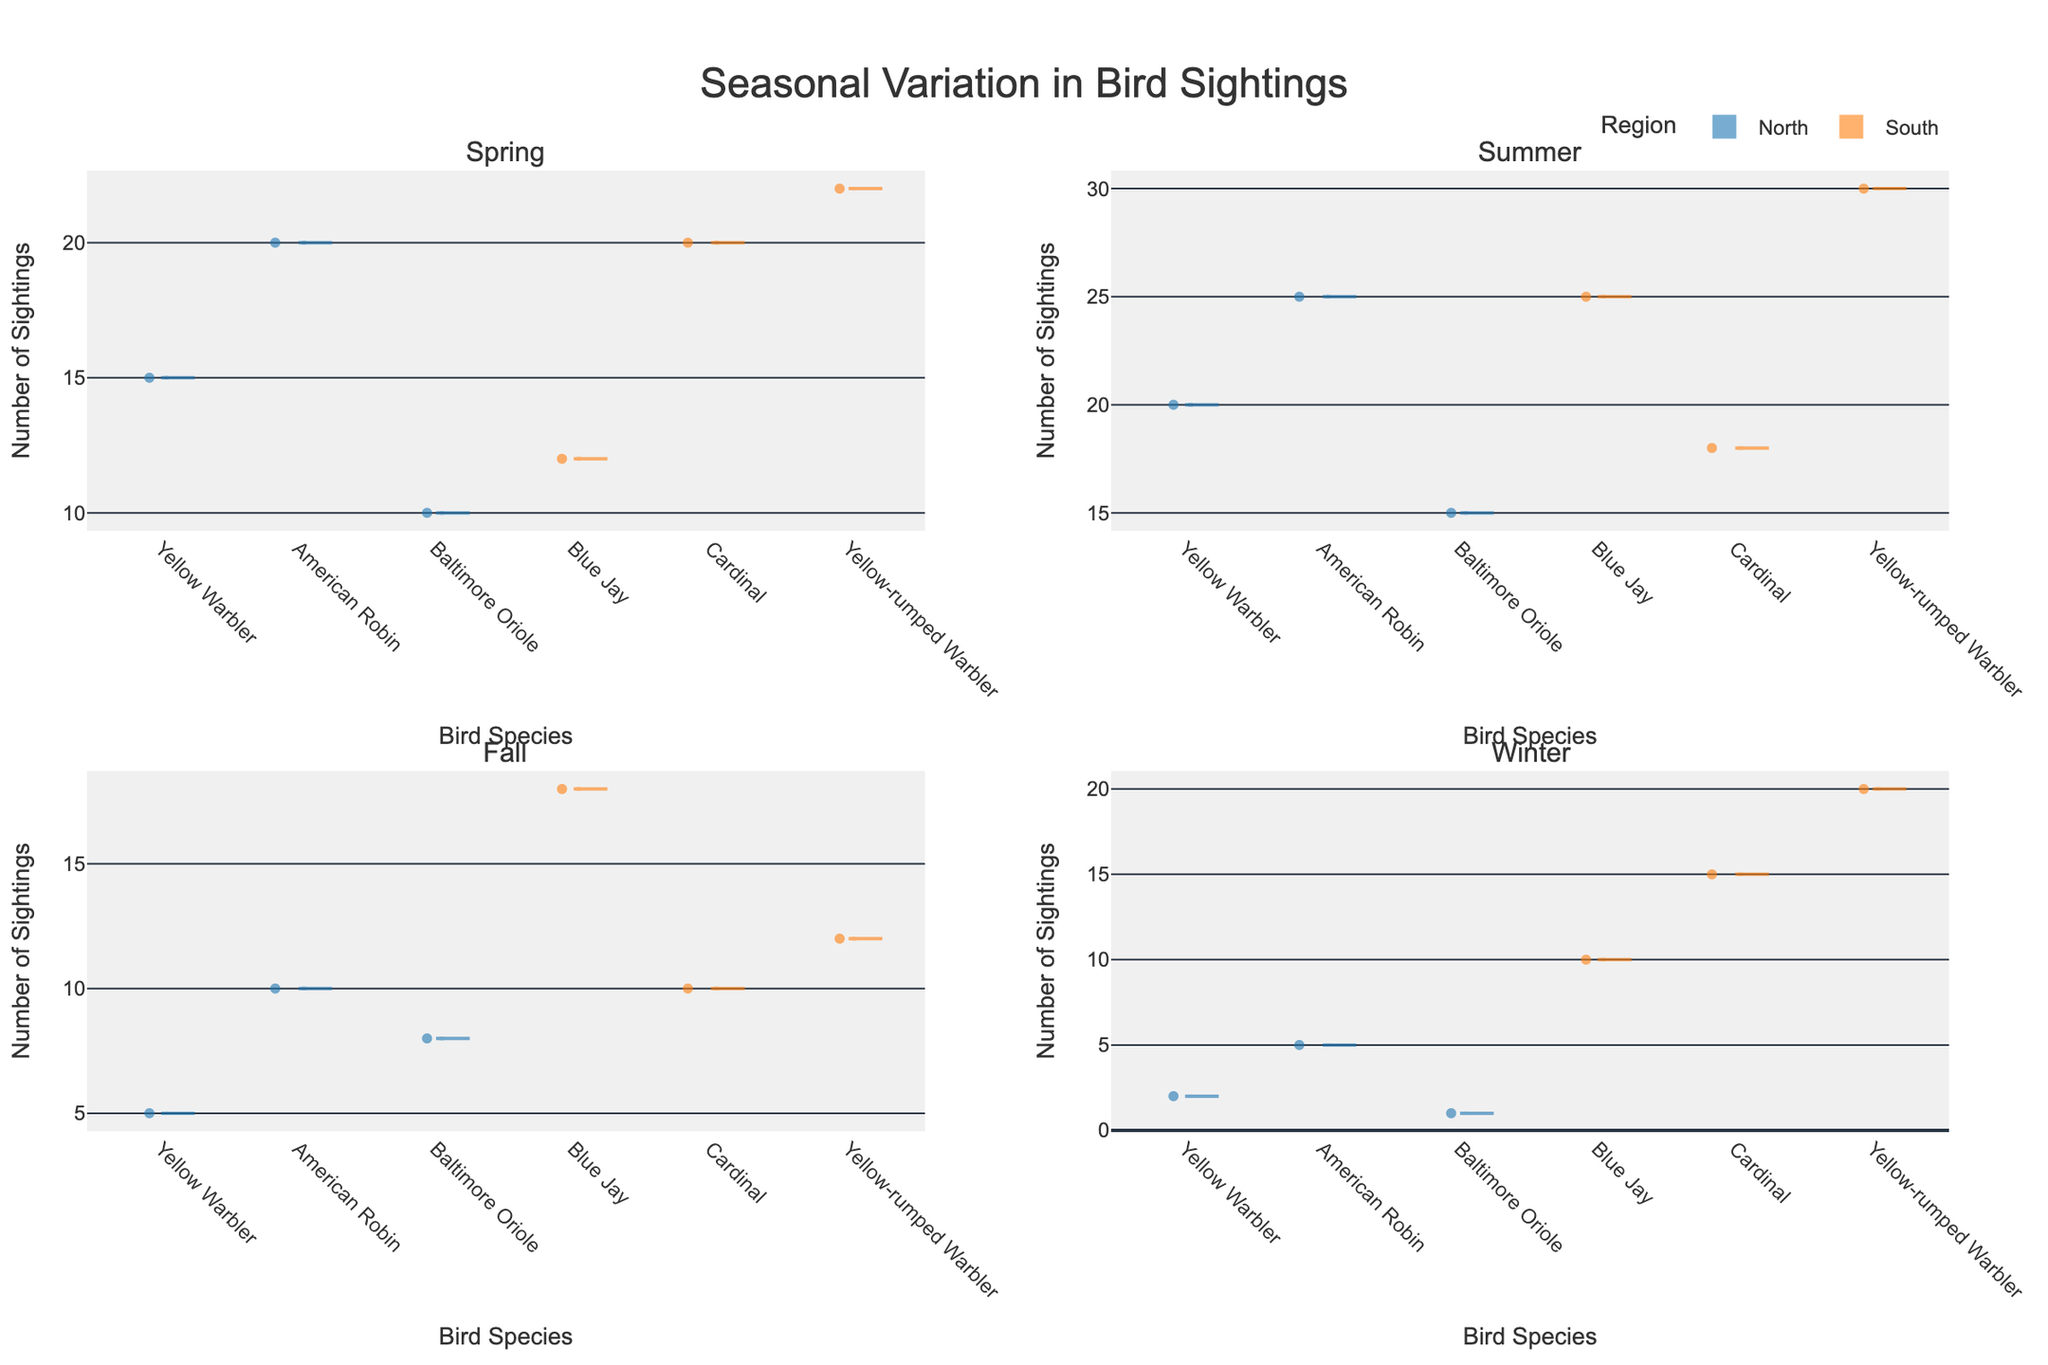What is the title of the plot? The title of the plot is located at the top center and reads "Seasonal Variation in Bird Sightings".
Answer: Seasonal Variation in Bird Sightings How many subplots are there in the figure? There are 4 subplots in the figure, arranged in a 2x2 grid. Each subplot represents a different season: Spring, Summer, Fall, and Winter.
Answer: 4 Which birds are represented in the Spring season? By looking at the x-axis labels in the Spring subplot (top-left), you can see the bird species: Yellow Warbler, American Robin, Baltimore Oriole in the North, and Blue Jay, Cardinal, Yellow-rumped Warbler in the South.
Answer: Yellow Warbler, American Robin, Baltimore Oriole, Blue Jay, Cardinal, Yellow-rumped Warbler In which season do Blue Jays have the highest number of sightings in the South region? By comparing the filled density of violin plots across each subplot, the peak for Blue Jay sightings in the South region appears highest in the Summer subplot.
Answer: Summer Compare the median number of sightings of Yellow Warblers in the North region between Spring and Winter. In the Spring subplot, the median line of Yellow Warbler for the North is higher compared to Winter. The Spring median is around 15, whereas Winter's is around 2.
Answer: Spring is higher During which season does the South region have the most variation in bird sightings? The most variation can be seen in the Summer subplot where the density spreads and range for South for Blue Jay, Cardinal, and Yellow-rumped Warbler is larger compared to other seasons.
Answer: Summer What's the general trend of American Robin sightings in the North region throughout the year? By observing the median points in each subplot, American Robin sightings peak in Summer, followed by Spring, decrease notably in Fall, and are lowest in Winter.
Answer: Increase in Summer, decrease afterward Are there any bird species in Winter that have sightings data only in one region? Yes, in the Winter subplot (bottom-right), Baltimore Oriole has data only in the North region with no sightings data available for the South.
Answer: Baltimore Oriole in North only Compare the highest number of sightings recorded for any bird species across the four seasons. By comparing the highest density peaks across all subplots, Yellow-rumped Warbler in the South region during Summer records the highest number of sightings.
Answer: Yellow-rumped Warbler in Summer, South 